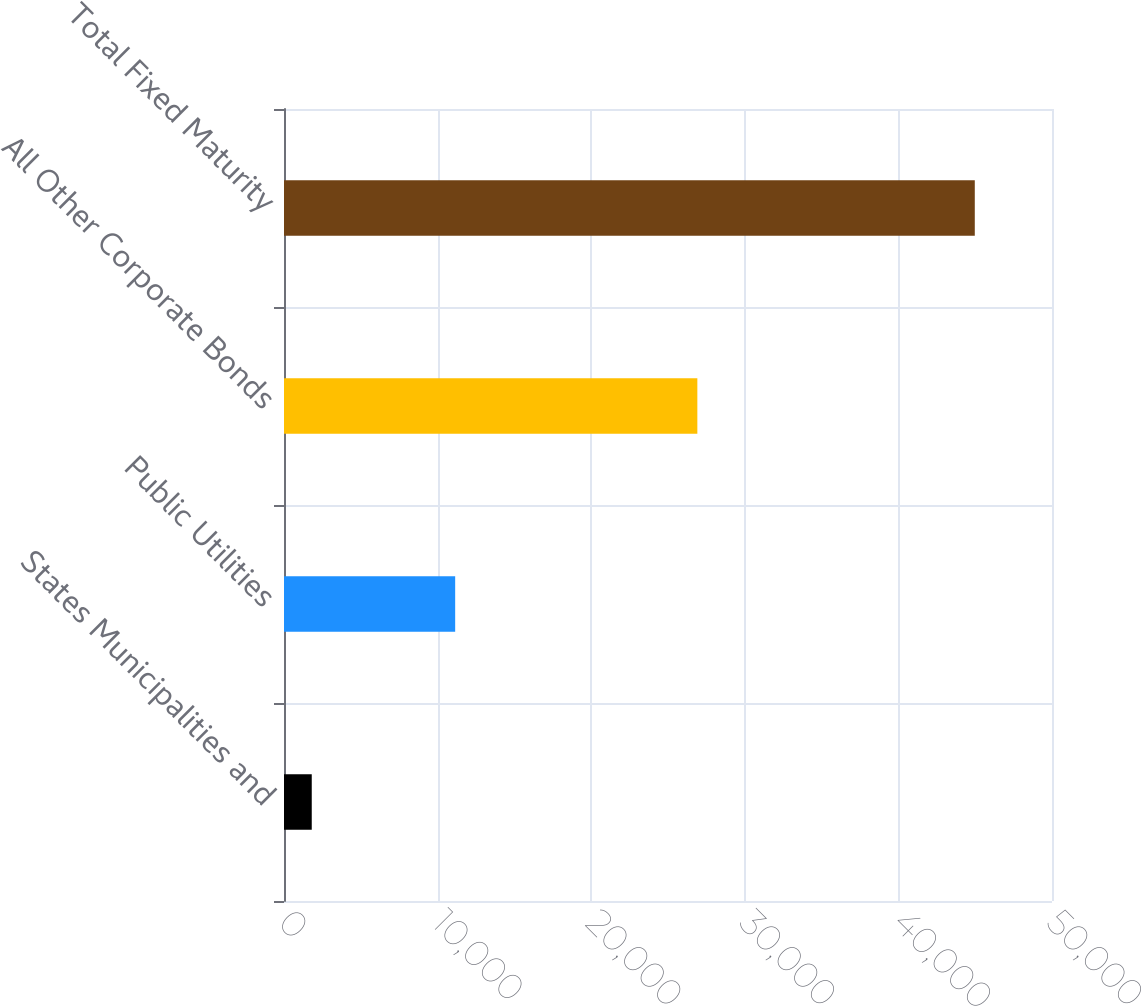Convert chart. <chart><loc_0><loc_0><loc_500><loc_500><bar_chart><fcel>States Municipalities and<fcel>Public Utilities<fcel>All Other Corporate Bonds<fcel>Total Fixed Maturity<nl><fcel>1806.8<fcel>11144.2<fcel>26910.4<fcel>44973<nl></chart> 